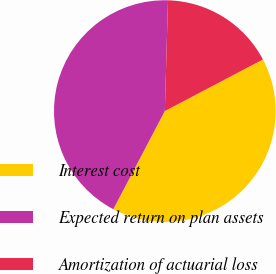Convert chart. <chart><loc_0><loc_0><loc_500><loc_500><pie_chart><fcel>Interest cost<fcel>Expected return on plan assets<fcel>Amortization of actuarial loss<nl><fcel>40.4%<fcel>42.76%<fcel>16.84%<nl></chart> 